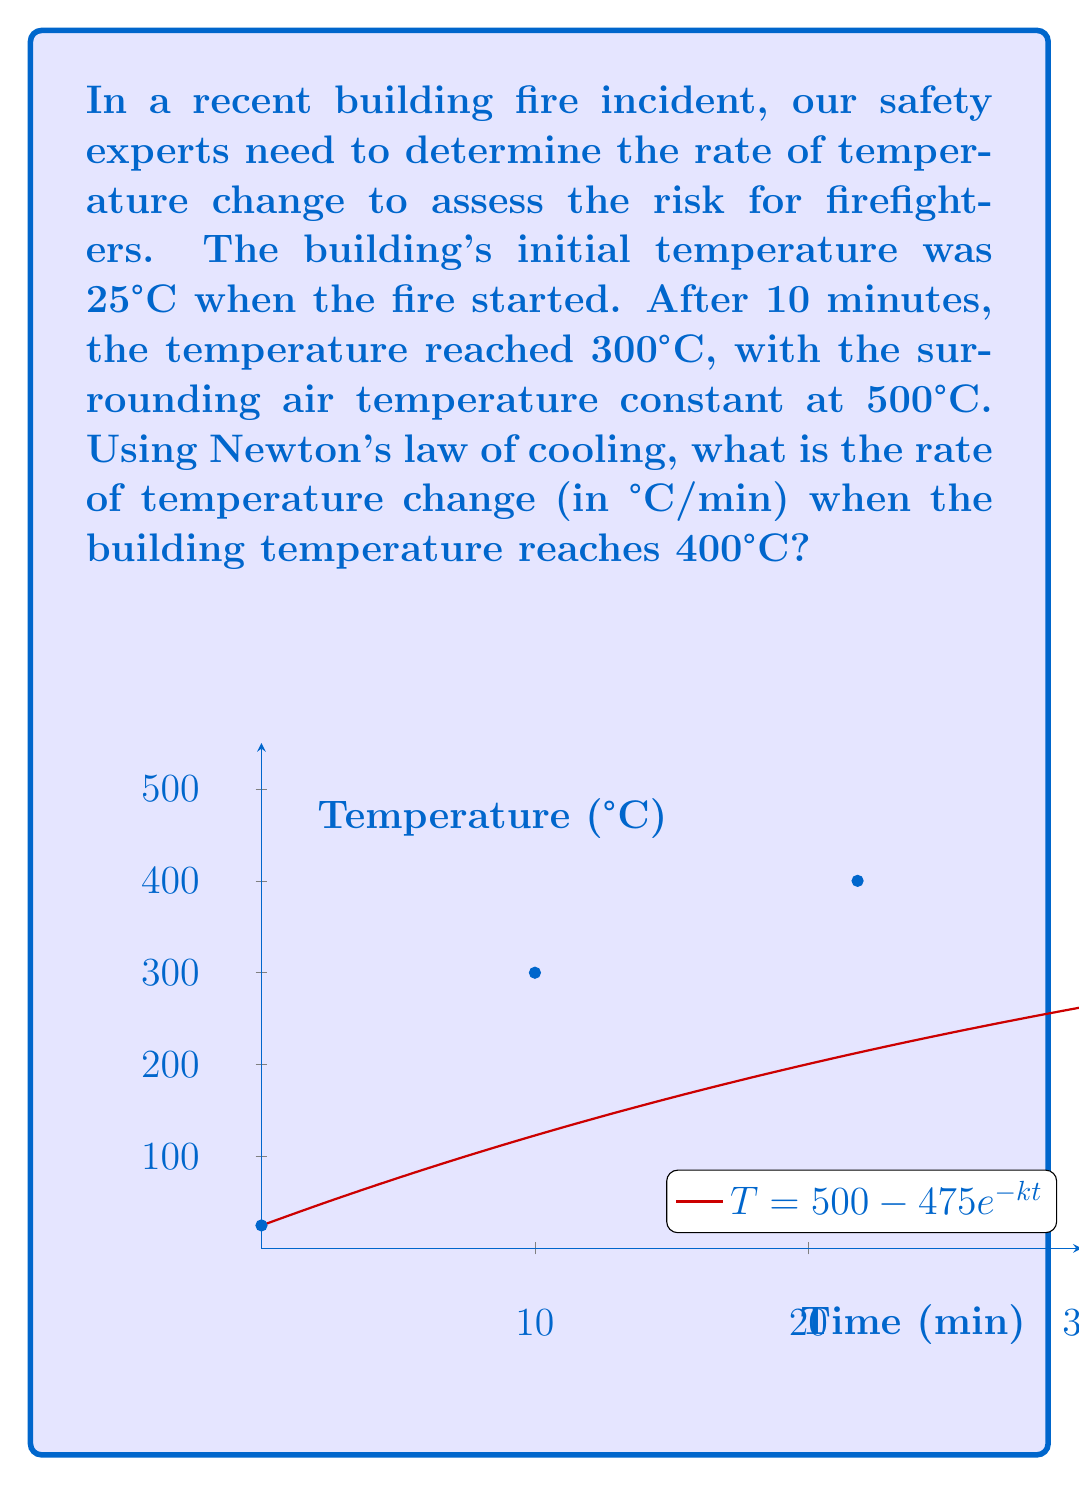Show me your answer to this math problem. Let's solve this step-by-step using Newton's law of cooling:

1) Newton's law of cooling is given by:
   $$\frac{dT}{dt} = k(T_s - T)$$
   where $T$ is the temperature of the object, $T_s$ is the surrounding temperature, and $k$ is the cooling constant.

2) We need to find $k$ first. The general solution to this differential equation is:
   $$T = T_s - (T_s - T_0)e^{-kt}$$

3) We know:
   - $T_s = 500°C$ (surrounding temperature)
   - $T_0 = 25°C$ (initial temperature)
   - At $t = 10$ minutes, $T = 300°C$

4) Substituting these values:
   $$300 = 500 - (500 - 25)e^{-10k}$$
   $$200 = 475e^{-10k}$$
   $$\ln(\frac{200}{475}) = -10k$$
   $$k = \frac{\ln(\frac{475}{200})}{10} \approx 0.0231 \text{ min}^{-1}$$

5) Now, we can find the rate of temperature change when $T = 400°C$:
   $$\frac{dT}{dt} = 0.0231(500 - 400) = 2.31 \text{ °C/min}$$
Answer: 2.31 °C/min 